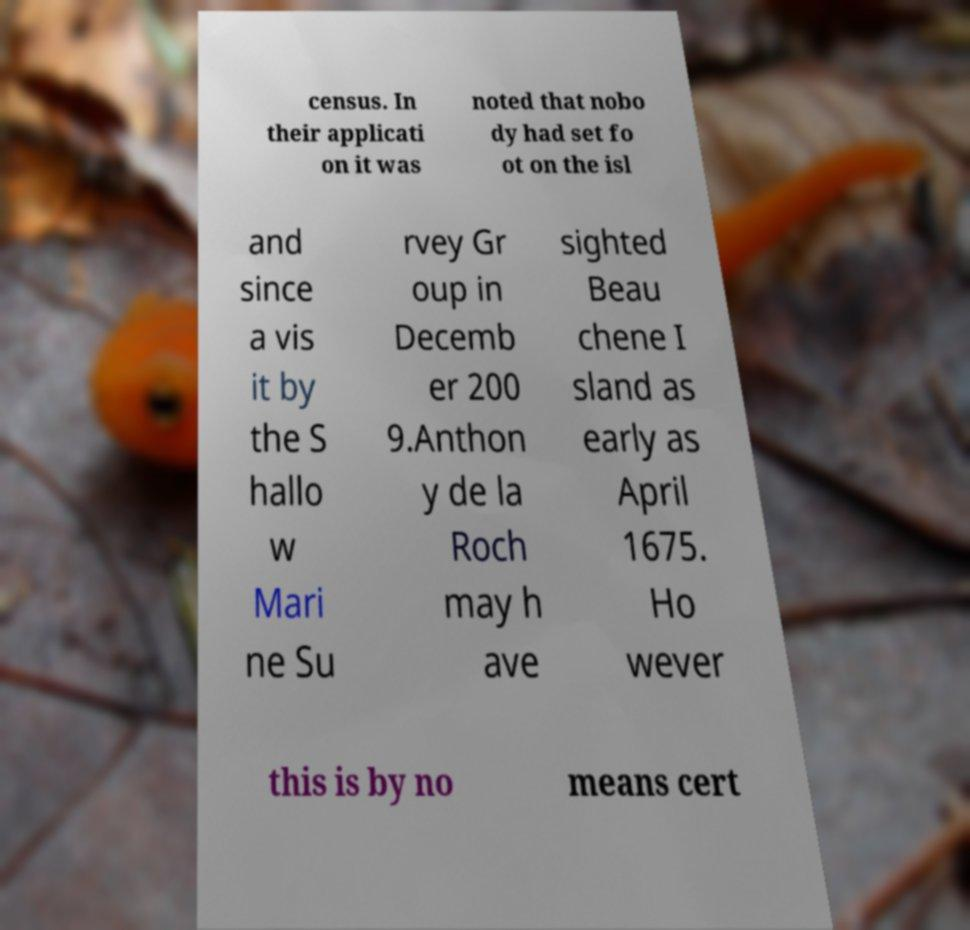Please read and relay the text visible in this image. What does it say? census. In their applicati on it was noted that nobo dy had set fo ot on the isl and since a vis it by the S hallo w Mari ne Su rvey Gr oup in Decemb er 200 9.Anthon y de la Roch may h ave sighted Beau chene I sland as early as April 1675. Ho wever this is by no means cert 